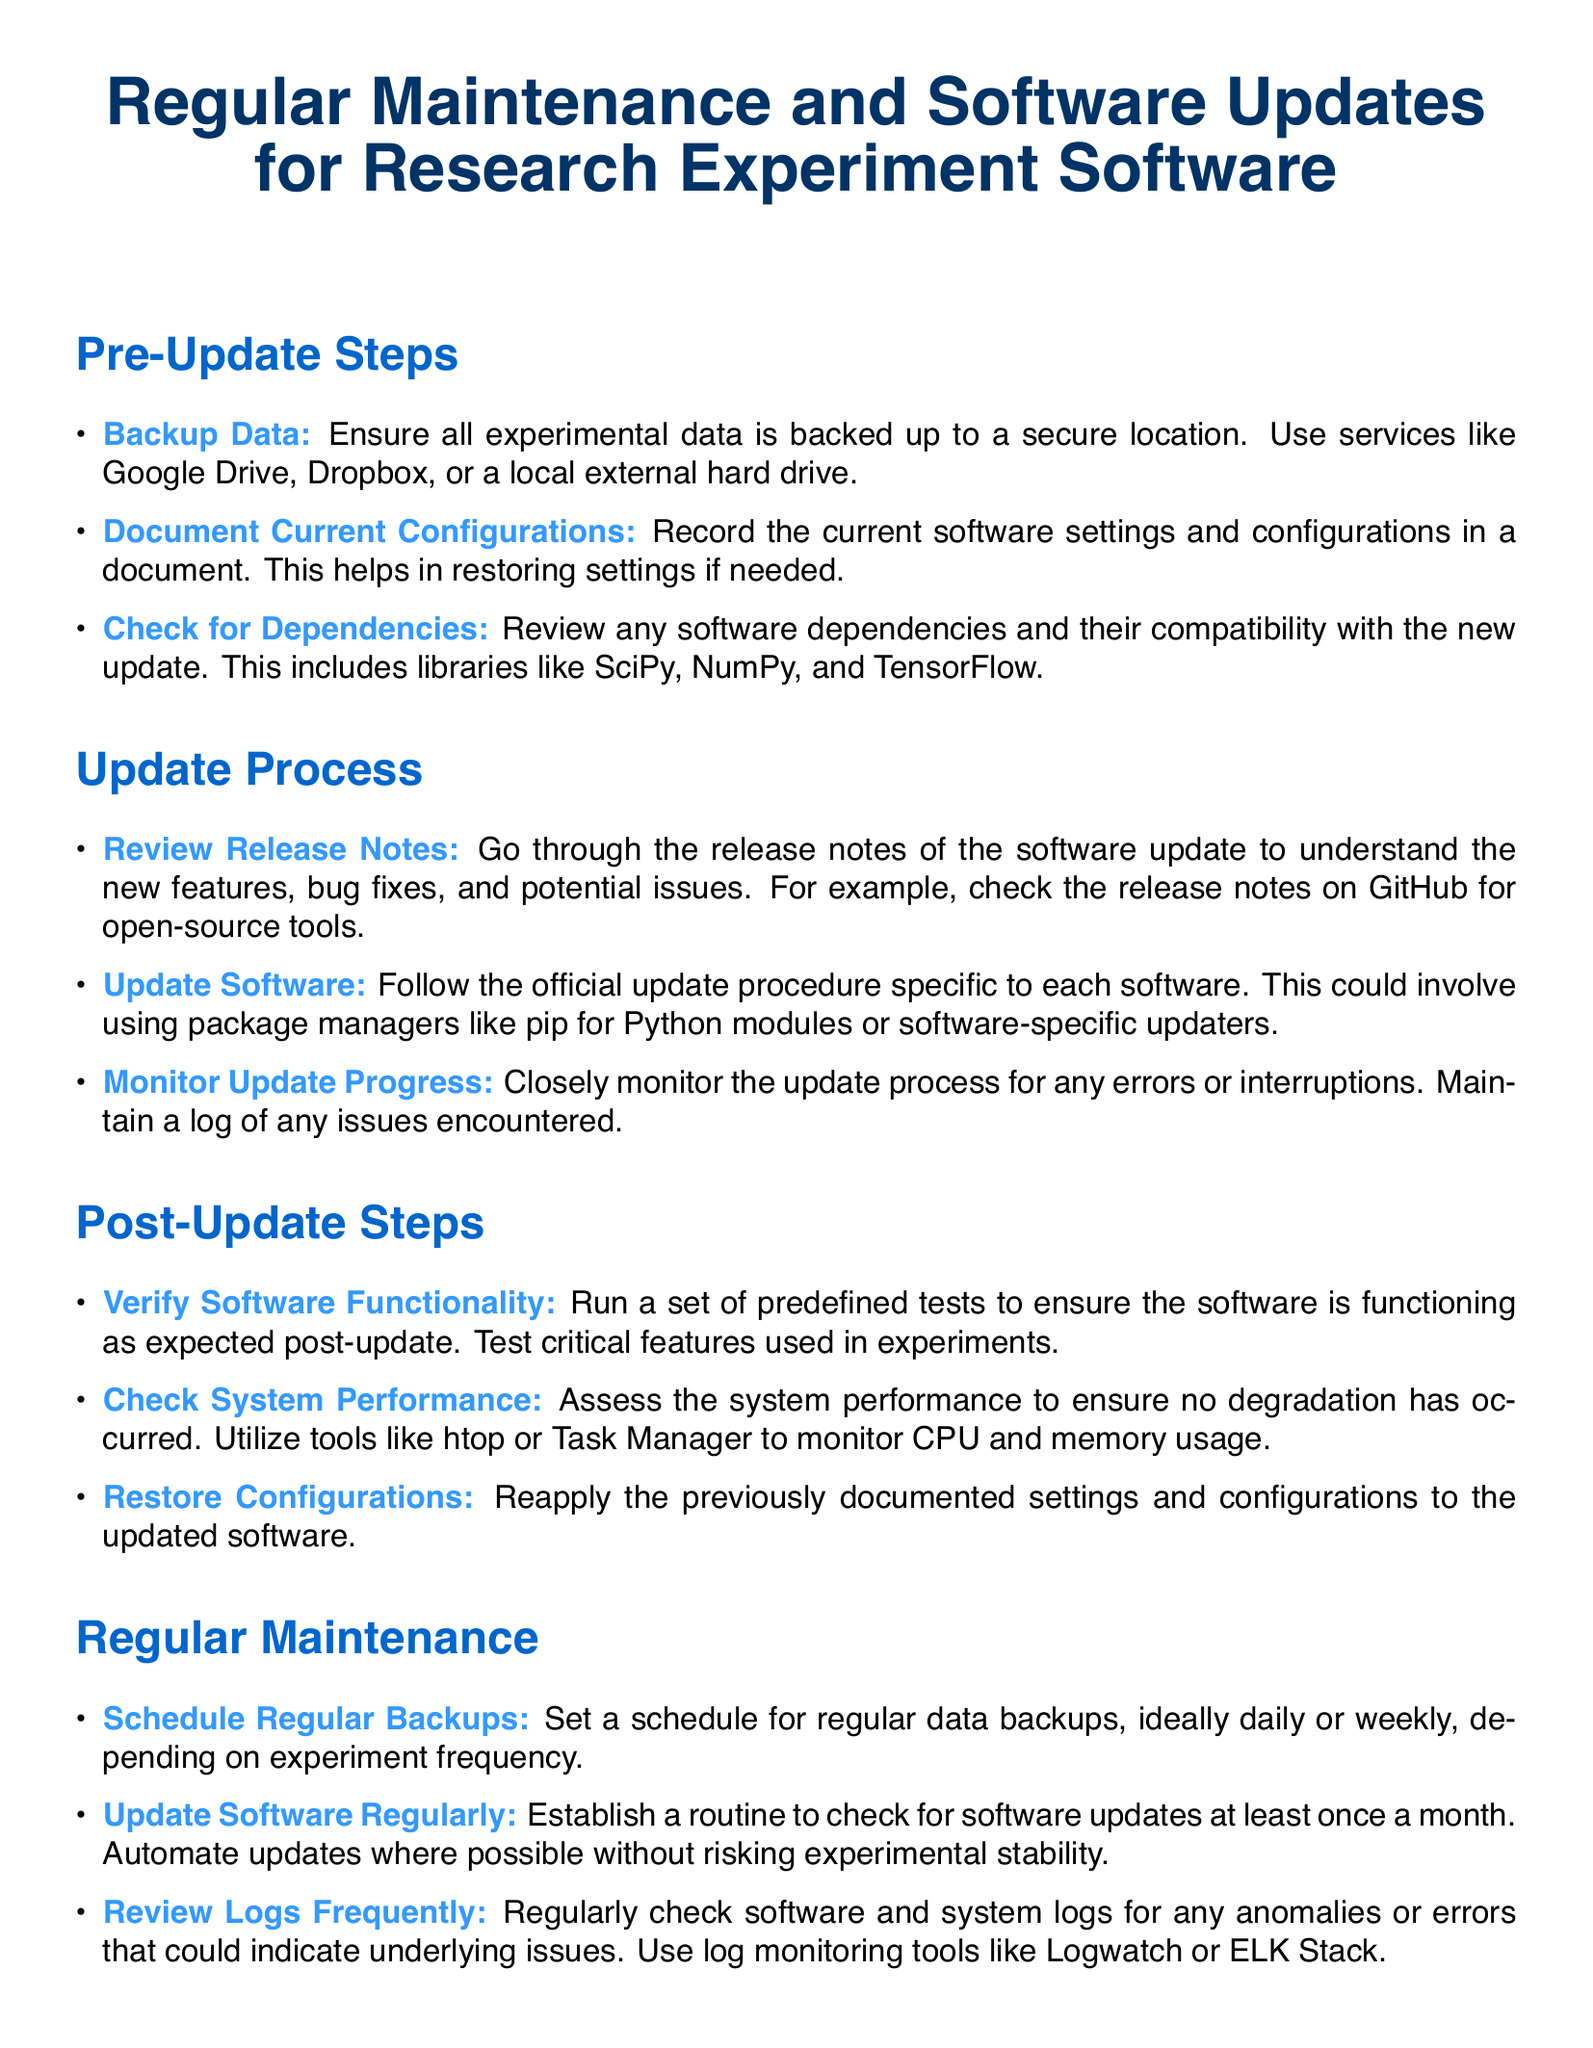What is the title of the document? The title is presented at the beginning of the document, highlighting its main focus.
Answer: Regular Maintenance and Software Updates for Research Experiment Software How many pre-update steps are listed? The number of pre-update steps is directly mentioned in the section.
Answer: 3 What is the first item in the update process? The first item appears in the "Update Process" section, indicating an important initial action.
Answer: Review Release Notes How often should software updates be checked? This frequency is specified in the "Regular Maintenance" section as part of good maintenance practice.
Answer: Once a month Name a tool suggested for monitoring system performance. The tool is mentioned in the "Post-Update Steps" section and is commonly used for performance monitoring.
Answer: htop What should be done to ensure data security? The document provides guidance on a critical task related to data protection.
Answer: Backup Data What is the purpose of documenting current configurations? The reason for this task is to help with future adjustments and troubleshooting, as stated in the document.
Answer: Restoring settings Which type of logs should be reviewed frequently? This specific type of logs is mentioned in the maintenance section for proactive system health checks.
Answer: Software and system logs What is a recommended tool for log monitoring? The document suggests a particular tool for effectively watching logs for issues.
Answer: ELK Stack 